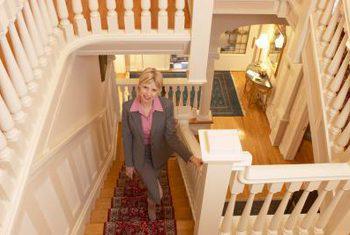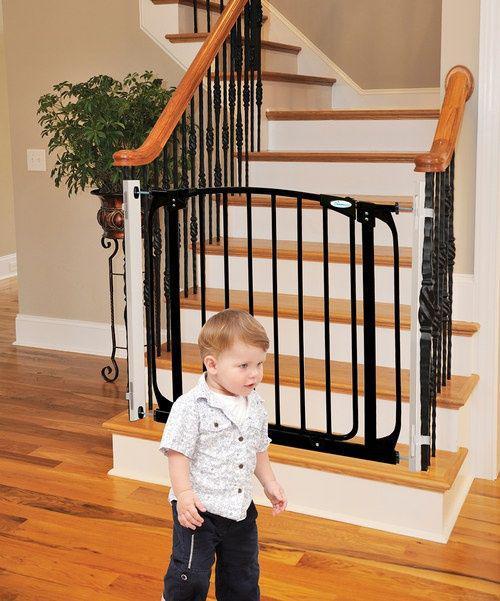The first image is the image on the left, the second image is the image on the right. Given the left and right images, does the statement "The right image shows a gate with vertical bars mounted to posts on each side to protect from falls, and a set of stairs is visible in the image." hold true? Answer yes or no. Yes. 